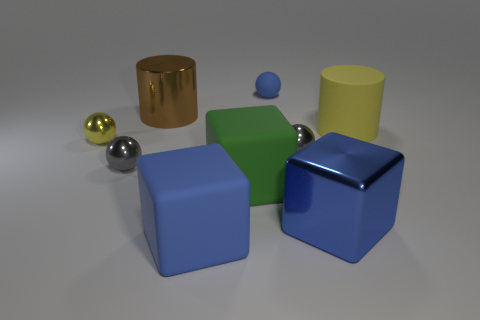Add 1 small blue objects. How many objects exist? 10 Subtract all big rubber cubes. How many cubes are left? 1 Subtract 1 cylinders. How many cylinders are left? 1 Subtract all yellow cylinders. How many cylinders are left? 1 Subtract all purple cubes. Subtract all blue cylinders. How many cubes are left? 3 Add 1 tiny metal objects. How many tiny metal objects are left? 4 Add 7 small purple matte things. How many small purple matte things exist? 7 Subtract 0 red cubes. How many objects are left? 9 Subtract all cylinders. How many objects are left? 7 Subtract all brown blocks. How many gray spheres are left? 2 